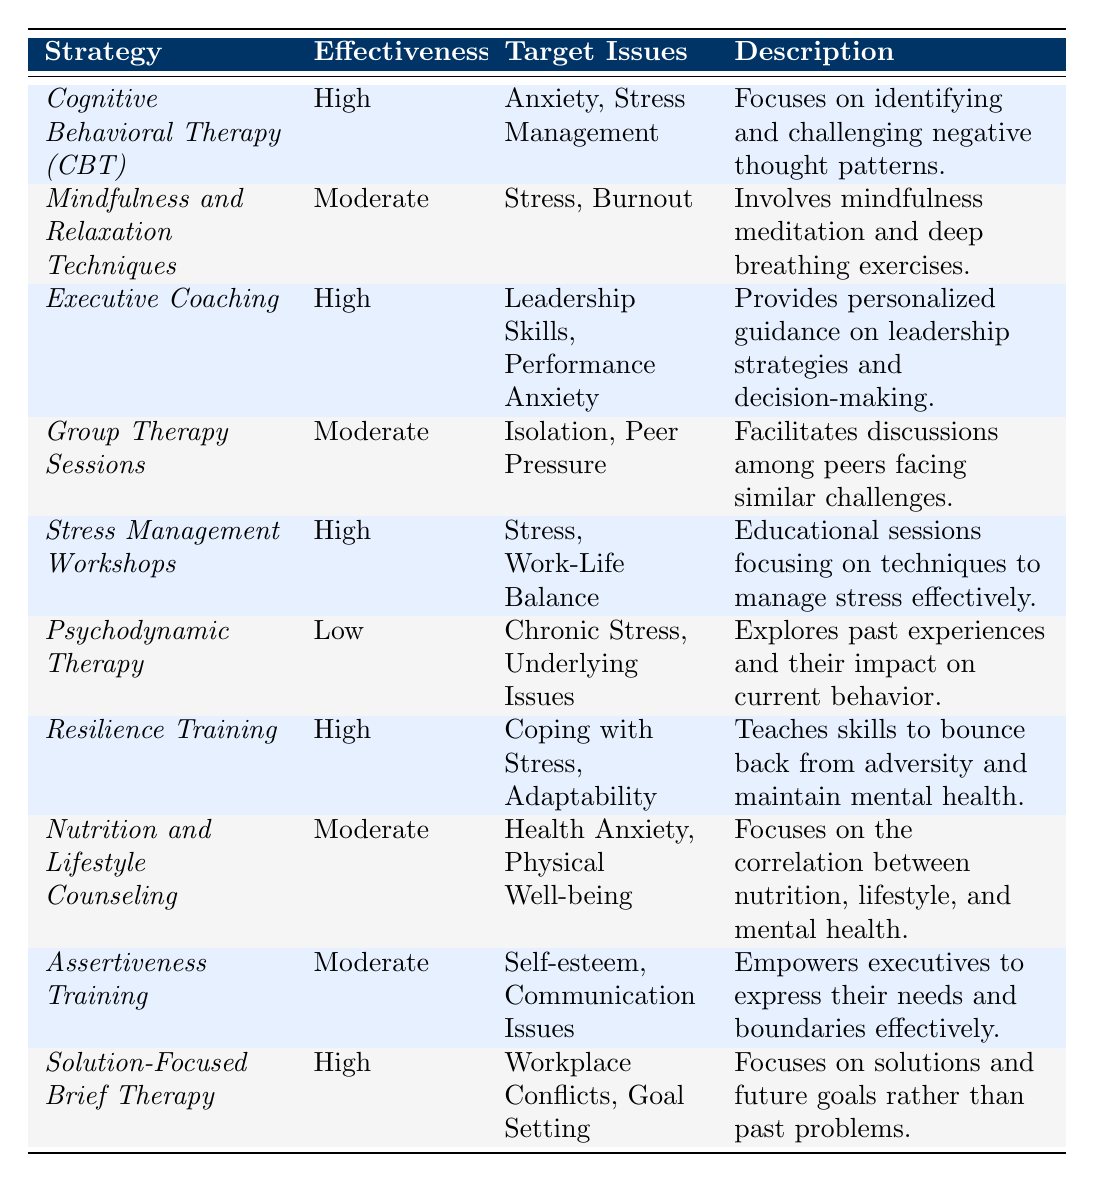What counseling strategy has the highest effectiveness rating? The table shows that "Cognitive Behavioral Therapy (CBT)," "Executive Coaching," "Stress Management Workshops," "Resilience Training," and "Solution-Focused Brief Therapy" all have a high effectiveness rating.
Answer: Cognitive Behavioral Therapy (CBT), Executive Coaching, Stress Management Workshops, Resilience Training, Solution-Focused Brief Therapy Which counseling strategy targets both Stress and Burnout? The table lists "Mindfulness and Relaxation Techniques," which has a moderate effectiveness rating, as targeting both Stress and Burnout.
Answer: Mindfulness and Relaxation Techniques Is Psychodynamic Therapy effective for chronic stress? The table indicates that Psychodynamic Therapy has a low effectiveness rating while targeting chronic stress and underlying issues. Therefore, it is not considered effective.
Answer: No How many strategies have a moderate effectiveness rating? By counting the entries in the table, we find that there are four strategies with a moderate effectiveness rating: "Mindfulness and Relaxation Techniques," "Group Therapy Sessions," "Nutrition and Lifestyle Counseling," and "Assertiveness Training."
Answer: 4 What is the effectiveness rating of Stress Management Workshops? The table specifies that the effectiveness rating of Stress Management Workshops is high.
Answer: High Which strategy focuses on solutions rather than past problems? The "Solution-Focused Brief Therapy" strategy explicitly states that it focuses on solutions and future goals instead of past problems.
Answer: Solution-Focused Brief Therapy What are the target issues for Resilience Training, and what is its effectiveness rating? The effectiveness rating for Resilience Training is high, and its target issues are "Coping with Stress" and "Adaptability," as shown in the table.
Answer: High; Coping with Stress, Adaptability Which counseling strategies have an effectiveness rating of low? The table indicates that only "Psychodynamic Therapy" has a low effectiveness rating.
Answer: Psychodynamic Therapy Which strategy is aimed at managing work-life balance? The "Stress Management Workshops" targets work-life balance and has a high effectiveness rating according to the table.
Answer: Stress Management Workshops If we combine the effectiveness ratings, how many strategies are rated high? There are five strategies rated as high effectiveness: CBT, Executive Coaching, Stress Management Workshops, Resilience Training, and Solution-Focused Brief Therapy. Therefore, combining those we get a total of five.
Answer: 5 